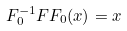<formula> <loc_0><loc_0><loc_500><loc_500>F ^ { - 1 } _ { 0 } F F _ { 0 } ( x ) = x</formula> 